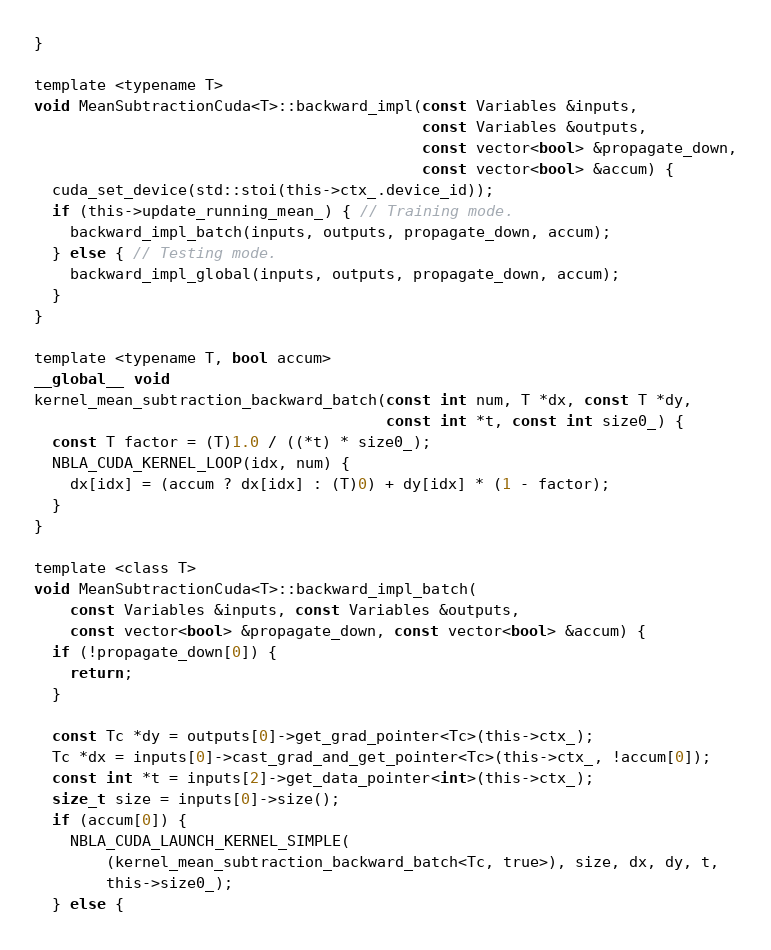<code> <loc_0><loc_0><loc_500><loc_500><_Cuda_>}

template <typename T>
void MeanSubtractionCuda<T>::backward_impl(const Variables &inputs,
                                           const Variables &outputs,
                                           const vector<bool> &propagate_down,
                                           const vector<bool> &accum) {
  cuda_set_device(std::stoi(this->ctx_.device_id));
  if (this->update_running_mean_) { // Training mode.
    backward_impl_batch(inputs, outputs, propagate_down, accum);
  } else { // Testing mode.
    backward_impl_global(inputs, outputs, propagate_down, accum);
  }
}

template <typename T, bool accum>
__global__ void
kernel_mean_subtraction_backward_batch(const int num, T *dx, const T *dy,
                                       const int *t, const int size0_) {
  const T factor = (T)1.0 / ((*t) * size0_);
  NBLA_CUDA_KERNEL_LOOP(idx, num) {
    dx[idx] = (accum ? dx[idx] : (T)0) + dy[idx] * (1 - factor);
  }
}

template <class T>
void MeanSubtractionCuda<T>::backward_impl_batch(
    const Variables &inputs, const Variables &outputs,
    const vector<bool> &propagate_down, const vector<bool> &accum) {
  if (!propagate_down[0]) {
    return;
  }

  const Tc *dy = outputs[0]->get_grad_pointer<Tc>(this->ctx_);
  Tc *dx = inputs[0]->cast_grad_and_get_pointer<Tc>(this->ctx_, !accum[0]);
  const int *t = inputs[2]->get_data_pointer<int>(this->ctx_);
  size_t size = inputs[0]->size();
  if (accum[0]) {
    NBLA_CUDA_LAUNCH_KERNEL_SIMPLE(
        (kernel_mean_subtraction_backward_batch<Tc, true>), size, dx, dy, t,
        this->size0_);
  } else {</code> 